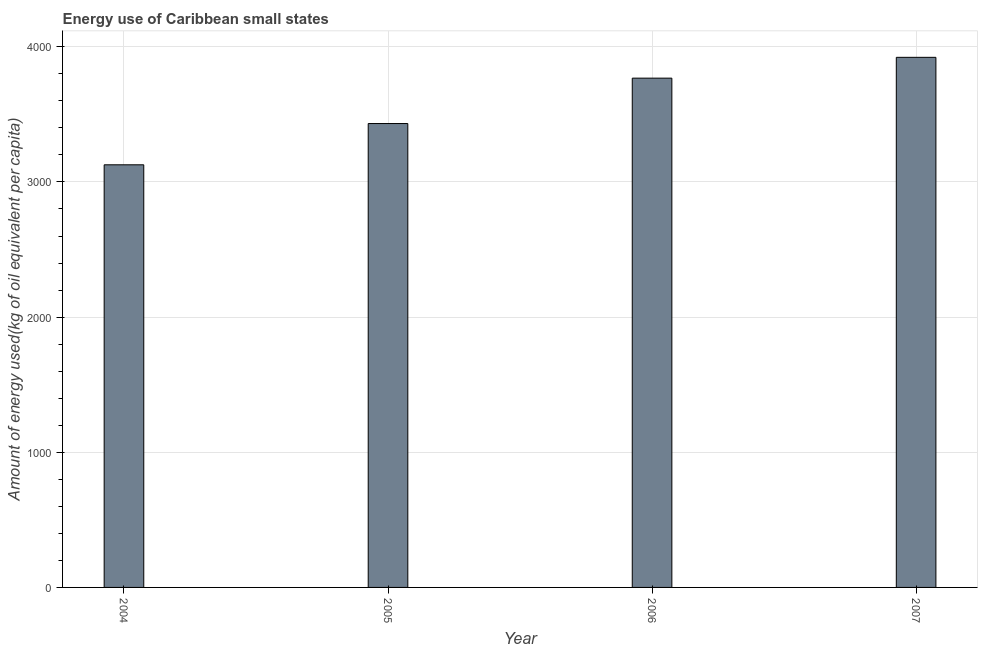Does the graph contain grids?
Keep it short and to the point. Yes. What is the title of the graph?
Your answer should be compact. Energy use of Caribbean small states. What is the label or title of the X-axis?
Ensure brevity in your answer.  Year. What is the label or title of the Y-axis?
Provide a short and direct response. Amount of energy used(kg of oil equivalent per capita). What is the amount of energy used in 2006?
Keep it short and to the point. 3768.15. Across all years, what is the maximum amount of energy used?
Your answer should be very brief. 3922.17. Across all years, what is the minimum amount of energy used?
Make the answer very short. 3126.98. In which year was the amount of energy used maximum?
Keep it short and to the point. 2007. In which year was the amount of energy used minimum?
Give a very brief answer. 2004. What is the sum of the amount of energy used?
Provide a short and direct response. 1.42e+04. What is the difference between the amount of energy used in 2005 and 2007?
Provide a succinct answer. -489.84. What is the average amount of energy used per year?
Make the answer very short. 3562.41. What is the median amount of energy used?
Keep it short and to the point. 3600.24. In how many years, is the amount of energy used greater than 3200 kg?
Provide a short and direct response. 3. What is the ratio of the amount of energy used in 2006 to that in 2007?
Keep it short and to the point. 0.96. What is the difference between the highest and the second highest amount of energy used?
Your response must be concise. 154.02. Is the sum of the amount of energy used in 2005 and 2007 greater than the maximum amount of energy used across all years?
Your answer should be compact. Yes. What is the difference between the highest and the lowest amount of energy used?
Offer a very short reply. 795.19. How many bars are there?
Make the answer very short. 4. Are all the bars in the graph horizontal?
Keep it short and to the point. No. What is the Amount of energy used(kg of oil equivalent per capita) of 2004?
Make the answer very short. 3126.98. What is the Amount of energy used(kg of oil equivalent per capita) of 2005?
Give a very brief answer. 3432.34. What is the Amount of energy used(kg of oil equivalent per capita) in 2006?
Offer a very short reply. 3768.15. What is the Amount of energy used(kg of oil equivalent per capita) of 2007?
Ensure brevity in your answer.  3922.17. What is the difference between the Amount of energy used(kg of oil equivalent per capita) in 2004 and 2005?
Your response must be concise. -305.35. What is the difference between the Amount of energy used(kg of oil equivalent per capita) in 2004 and 2006?
Offer a terse response. -641.17. What is the difference between the Amount of energy used(kg of oil equivalent per capita) in 2004 and 2007?
Offer a very short reply. -795.19. What is the difference between the Amount of energy used(kg of oil equivalent per capita) in 2005 and 2006?
Your answer should be very brief. -335.82. What is the difference between the Amount of energy used(kg of oil equivalent per capita) in 2005 and 2007?
Offer a very short reply. -489.84. What is the difference between the Amount of energy used(kg of oil equivalent per capita) in 2006 and 2007?
Ensure brevity in your answer.  -154.02. What is the ratio of the Amount of energy used(kg of oil equivalent per capita) in 2004 to that in 2005?
Offer a very short reply. 0.91. What is the ratio of the Amount of energy used(kg of oil equivalent per capita) in 2004 to that in 2006?
Give a very brief answer. 0.83. What is the ratio of the Amount of energy used(kg of oil equivalent per capita) in 2004 to that in 2007?
Provide a succinct answer. 0.8. What is the ratio of the Amount of energy used(kg of oil equivalent per capita) in 2005 to that in 2006?
Your response must be concise. 0.91. What is the ratio of the Amount of energy used(kg of oil equivalent per capita) in 2005 to that in 2007?
Offer a terse response. 0.88. 